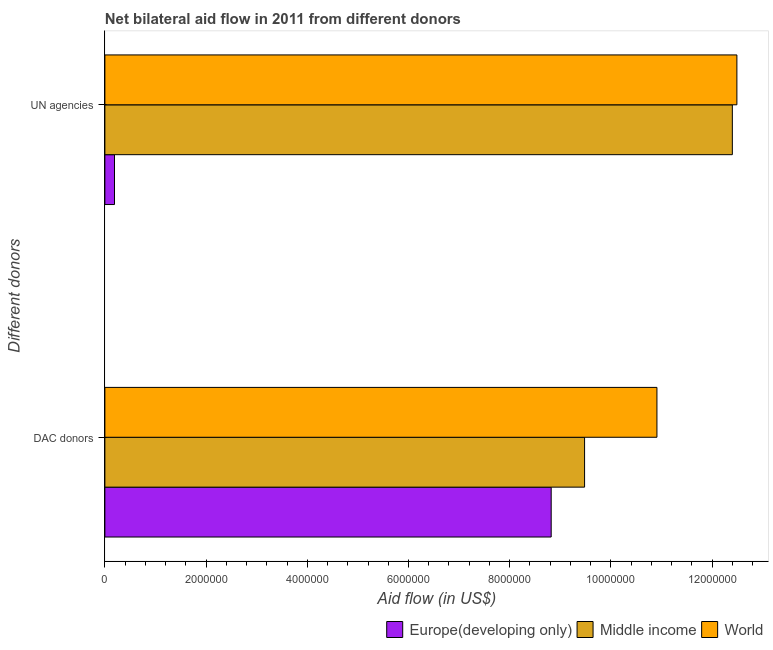Are the number of bars per tick equal to the number of legend labels?
Your answer should be very brief. Yes. Are the number of bars on each tick of the Y-axis equal?
Keep it short and to the point. Yes. How many bars are there on the 1st tick from the top?
Offer a terse response. 3. How many bars are there on the 1st tick from the bottom?
Offer a very short reply. 3. What is the label of the 1st group of bars from the top?
Ensure brevity in your answer.  UN agencies. What is the aid flow from dac donors in Europe(developing only)?
Provide a short and direct response. 8.82e+06. Across all countries, what is the maximum aid flow from dac donors?
Your answer should be compact. 1.09e+07. Across all countries, what is the minimum aid flow from un agencies?
Provide a short and direct response. 1.90e+05. In which country was the aid flow from dac donors minimum?
Give a very brief answer. Europe(developing only). What is the total aid flow from un agencies in the graph?
Make the answer very short. 2.51e+07. What is the difference between the aid flow from dac donors in Europe(developing only) and that in World?
Keep it short and to the point. -2.09e+06. What is the difference between the aid flow from un agencies in Europe(developing only) and the aid flow from dac donors in World?
Keep it short and to the point. -1.07e+07. What is the average aid flow from dac donors per country?
Your response must be concise. 9.74e+06. What is the difference between the aid flow from dac donors and aid flow from un agencies in Europe(developing only)?
Your answer should be very brief. 8.63e+06. In how many countries, is the aid flow from un agencies greater than 10800000 US$?
Provide a short and direct response. 2. What is the ratio of the aid flow from un agencies in World to that in Europe(developing only)?
Offer a terse response. 65.74. Is the aid flow from dac donors in World less than that in Europe(developing only)?
Your response must be concise. No. In how many countries, is the aid flow from un agencies greater than the average aid flow from un agencies taken over all countries?
Ensure brevity in your answer.  2. What does the 3rd bar from the top in UN agencies represents?
Give a very brief answer. Europe(developing only). What does the 3rd bar from the bottom in DAC donors represents?
Make the answer very short. World. Are all the bars in the graph horizontal?
Offer a terse response. Yes. Are the values on the major ticks of X-axis written in scientific E-notation?
Keep it short and to the point. No. Does the graph contain grids?
Provide a short and direct response. No. What is the title of the graph?
Provide a short and direct response. Net bilateral aid flow in 2011 from different donors. Does "Eritrea" appear as one of the legend labels in the graph?
Offer a terse response. No. What is the label or title of the X-axis?
Make the answer very short. Aid flow (in US$). What is the label or title of the Y-axis?
Offer a terse response. Different donors. What is the Aid flow (in US$) of Europe(developing only) in DAC donors?
Make the answer very short. 8.82e+06. What is the Aid flow (in US$) in Middle income in DAC donors?
Your answer should be compact. 9.48e+06. What is the Aid flow (in US$) of World in DAC donors?
Your response must be concise. 1.09e+07. What is the Aid flow (in US$) of Europe(developing only) in UN agencies?
Ensure brevity in your answer.  1.90e+05. What is the Aid flow (in US$) in Middle income in UN agencies?
Provide a short and direct response. 1.24e+07. What is the Aid flow (in US$) in World in UN agencies?
Offer a very short reply. 1.25e+07. Across all Different donors, what is the maximum Aid flow (in US$) in Europe(developing only)?
Provide a succinct answer. 8.82e+06. Across all Different donors, what is the maximum Aid flow (in US$) in Middle income?
Make the answer very short. 1.24e+07. Across all Different donors, what is the maximum Aid flow (in US$) in World?
Offer a terse response. 1.25e+07. Across all Different donors, what is the minimum Aid flow (in US$) of Middle income?
Your answer should be very brief. 9.48e+06. Across all Different donors, what is the minimum Aid flow (in US$) of World?
Your response must be concise. 1.09e+07. What is the total Aid flow (in US$) of Europe(developing only) in the graph?
Make the answer very short. 9.01e+06. What is the total Aid flow (in US$) of Middle income in the graph?
Offer a terse response. 2.19e+07. What is the total Aid flow (in US$) in World in the graph?
Ensure brevity in your answer.  2.34e+07. What is the difference between the Aid flow (in US$) in Europe(developing only) in DAC donors and that in UN agencies?
Your response must be concise. 8.63e+06. What is the difference between the Aid flow (in US$) of Middle income in DAC donors and that in UN agencies?
Keep it short and to the point. -2.92e+06. What is the difference between the Aid flow (in US$) in World in DAC donors and that in UN agencies?
Keep it short and to the point. -1.58e+06. What is the difference between the Aid flow (in US$) in Europe(developing only) in DAC donors and the Aid flow (in US$) in Middle income in UN agencies?
Your answer should be very brief. -3.58e+06. What is the difference between the Aid flow (in US$) in Europe(developing only) in DAC donors and the Aid flow (in US$) in World in UN agencies?
Offer a terse response. -3.67e+06. What is the difference between the Aid flow (in US$) in Middle income in DAC donors and the Aid flow (in US$) in World in UN agencies?
Keep it short and to the point. -3.01e+06. What is the average Aid flow (in US$) of Europe(developing only) per Different donors?
Offer a very short reply. 4.50e+06. What is the average Aid flow (in US$) in Middle income per Different donors?
Your answer should be very brief. 1.09e+07. What is the average Aid flow (in US$) in World per Different donors?
Make the answer very short. 1.17e+07. What is the difference between the Aid flow (in US$) in Europe(developing only) and Aid flow (in US$) in Middle income in DAC donors?
Your answer should be very brief. -6.60e+05. What is the difference between the Aid flow (in US$) of Europe(developing only) and Aid flow (in US$) of World in DAC donors?
Give a very brief answer. -2.09e+06. What is the difference between the Aid flow (in US$) in Middle income and Aid flow (in US$) in World in DAC donors?
Offer a very short reply. -1.43e+06. What is the difference between the Aid flow (in US$) in Europe(developing only) and Aid flow (in US$) in Middle income in UN agencies?
Ensure brevity in your answer.  -1.22e+07. What is the difference between the Aid flow (in US$) in Europe(developing only) and Aid flow (in US$) in World in UN agencies?
Your answer should be very brief. -1.23e+07. What is the difference between the Aid flow (in US$) of Middle income and Aid flow (in US$) of World in UN agencies?
Make the answer very short. -9.00e+04. What is the ratio of the Aid flow (in US$) in Europe(developing only) in DAC donors to that in UN agencies?
Your response must be concise. 46.42. What is the ratio of the Aid flow (in US$) of Middle income in DAC donors to that in UN agencies?
Ensure brevity in your answer.  0.76. What is the ratio of the Aid flow (in US$) of World in DAC donors to that in UN agencies?
Ensure brevity in your answer.  0.87. What is the difference between the highest and the second highest Aid flow (in US$) in Europe(developing only)?
Provide a short and direct response. 8.63e+06. What is the difference between the highest and the second highest Aid flow (in US$) in Middle income?
Ensure brevity in your answer.  2.92e+06. What is the difference between the highest and the second highest Aid flow (in US$) in World?
Make the answer very short. 1.58e+06. What is the difference between the highest and the lowest Aid flow (in US$) of Europe(developing only)?
Your response must be concise. 8.63e+06. What is the difference between the highest and the lowest Aid flow (in US$) of Middle income?
Provide a short and direct response. 2.92e+06. What is the difference between the highest and the lowest Aid flow (in US$) of World?
Ensure brevity in your answer.  1.58e+06. 